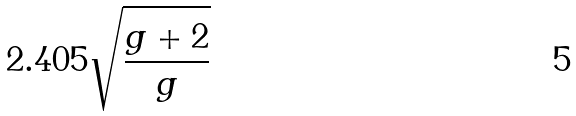Convert formula to latex. <formula><loc_0><loc_0><loc_500><loc_500>2 . 4 0 5 \sqrt { \frac { g + 2 } { g } }</formula> 